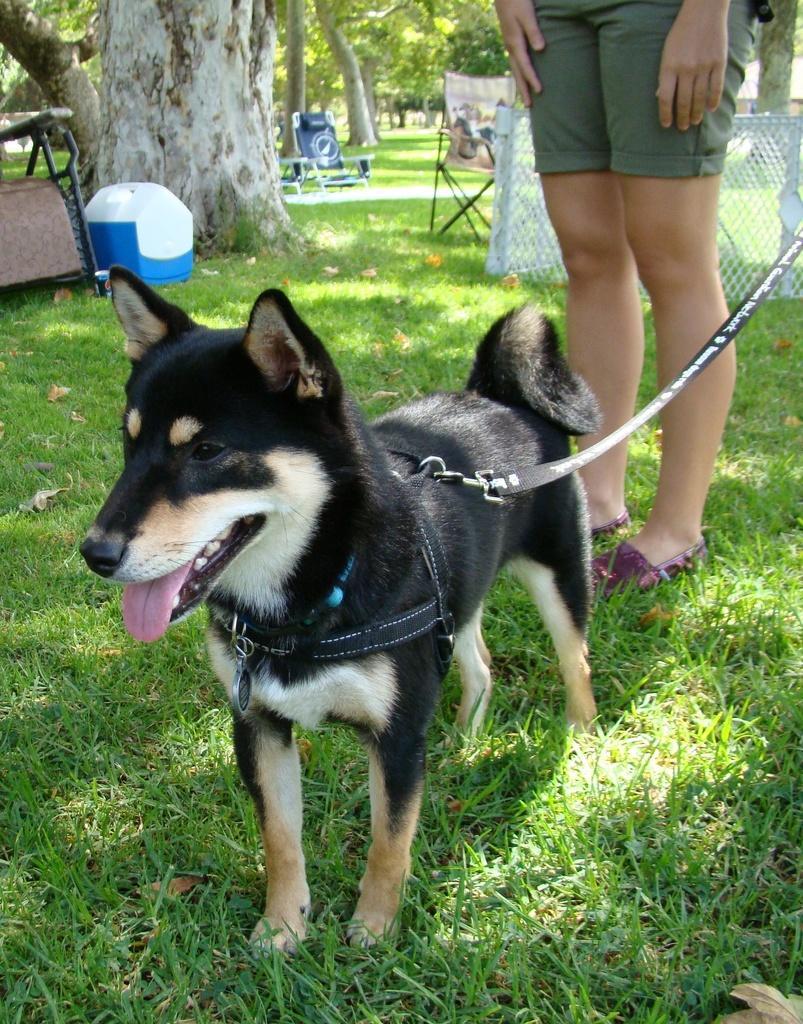Can you describe this image briefly? In the foreground of the picture there are dry leaves, grass and a dog. In the center of the picture there is a person standing. At the top there are trees. In the center of the background there are chairs. On the right there is net. On the left there is a chair and a box. 